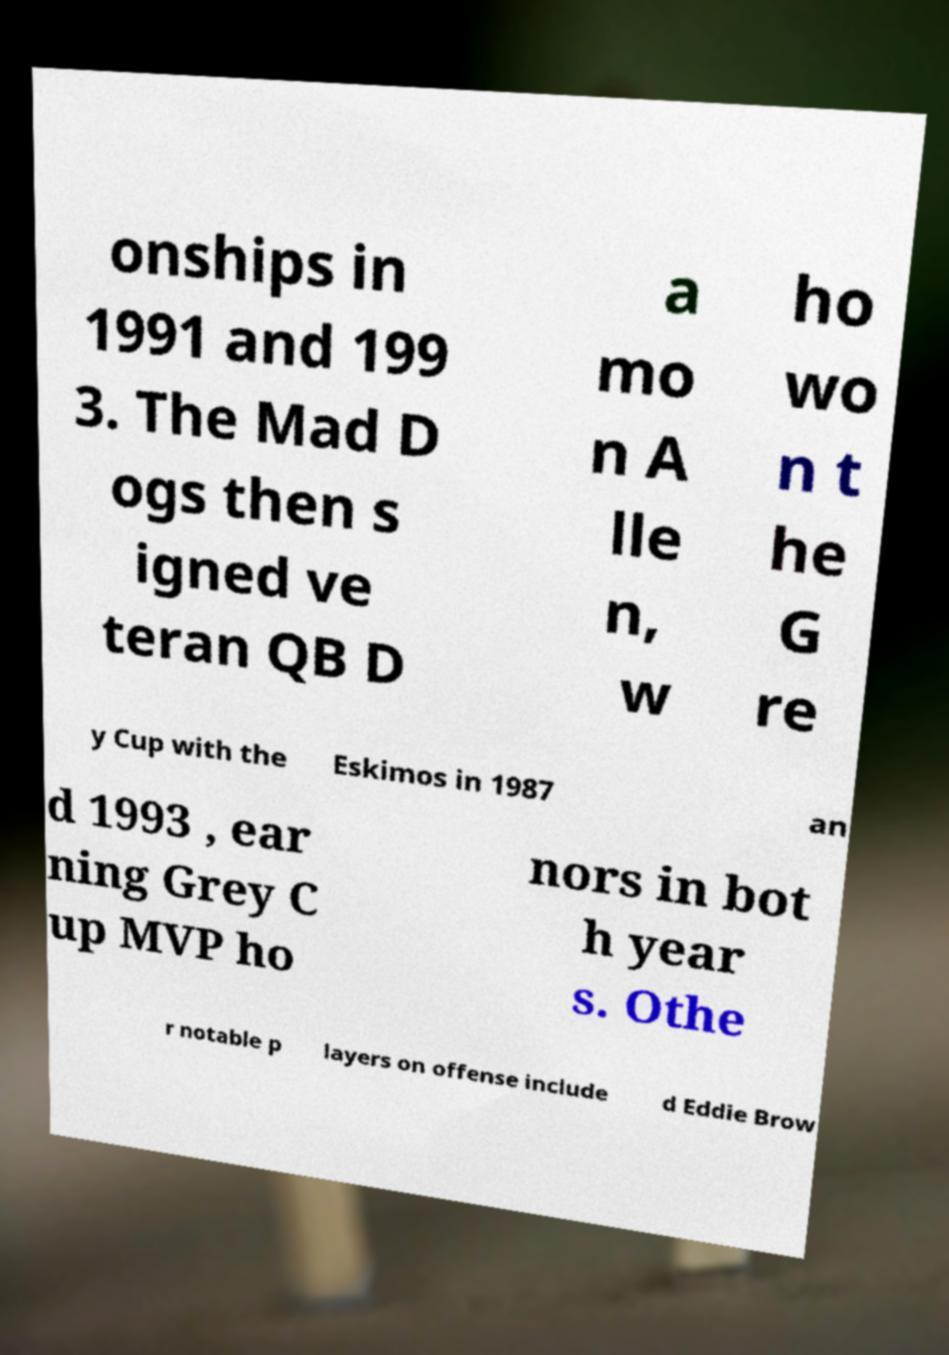Can you accurately transcribe the text from the provided image for me? onships in 1991 and 199 3. The Mad D ogs then s igned ve teran QB D a mo n A lle n, w ho wo n t he G re y Cup with the Eskimos in 1987 an d 1993 , ear ning Grey C up MVP ho nors in bot h year s. Othe r notable p layers on offense include d Eddie Brow 